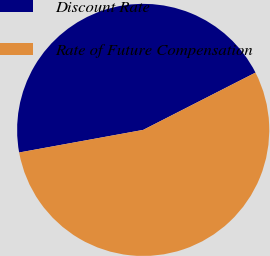<chart> <loc_0><loc_0><loc_500><loc_500><pie_chart><fcel>Discount Rate<fcel>Rate of Future Compensation<nl><fcel>45.36%<fcel>54.64%<nl></chart> 